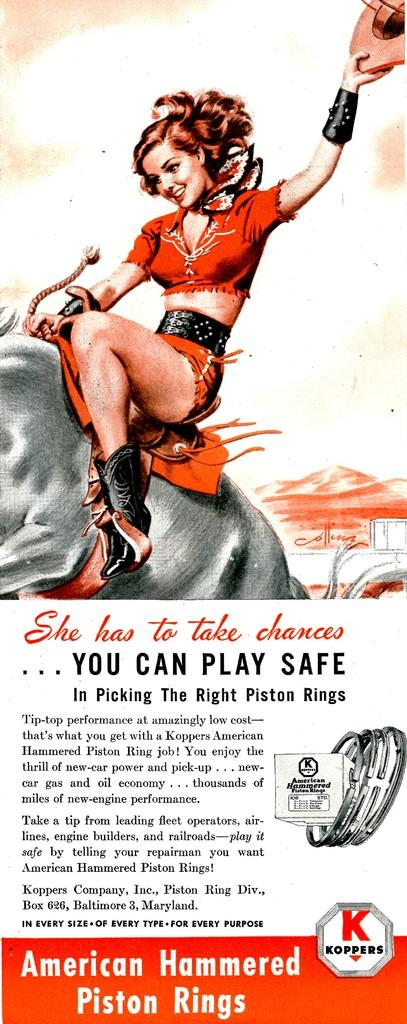What type of visual is the image? The image is a poster. Who or what is depicted in the poster? There is a person depicted in the poster. What is the person doing in the poster? The person is holding an object and sitting on an animal. What else can be found on the poster besides the person and the animal? There is text and pictures on the poster. What type of zephyr is being ridden by the person in the poster? There is no mention of a zephyr in the image or the provided facts. The person is sitting on an animal, but it is not specified as a zephyr. 